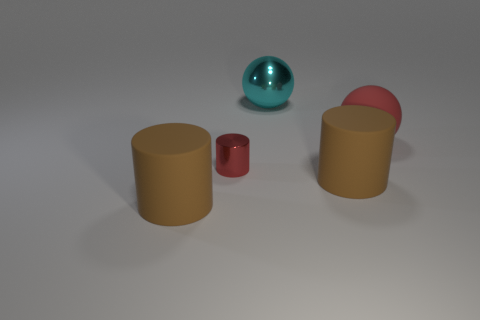Subtract all brown matte cylinders. How many cylinders are left? 1 Subtract all brown blocks. How many brown cylinders are left? 2 Subtract all red cylinders. How many cylinders are left? 2 Subtract 1 cylinders. How many cylinders are left? 2 Add 2 yellow cylinders. How many objects exist? 7 Add 3 red cylinders. How many red cylinders exist? 4 Subtract 0 blue balls. How many objects are left? 5 Subtract all cylinders. How many objects are left? 2 Subtract all green cylinders. Subtract all gray balls. How many cylinders are left? 3 Subtract all large brown rubber things. Subtract all large matte cylinders. How many objects are left? 1 